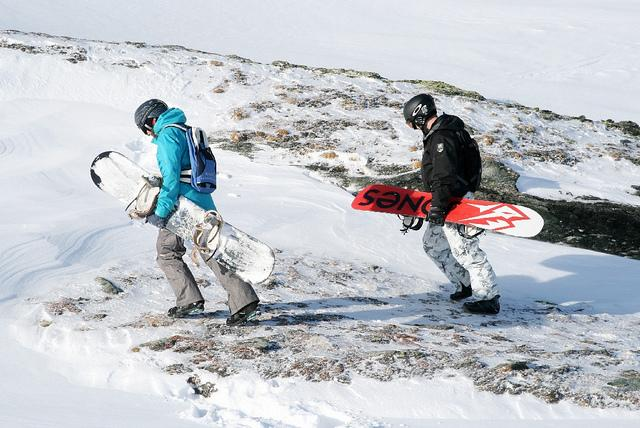What name is on the bottom of the ski board? ones 